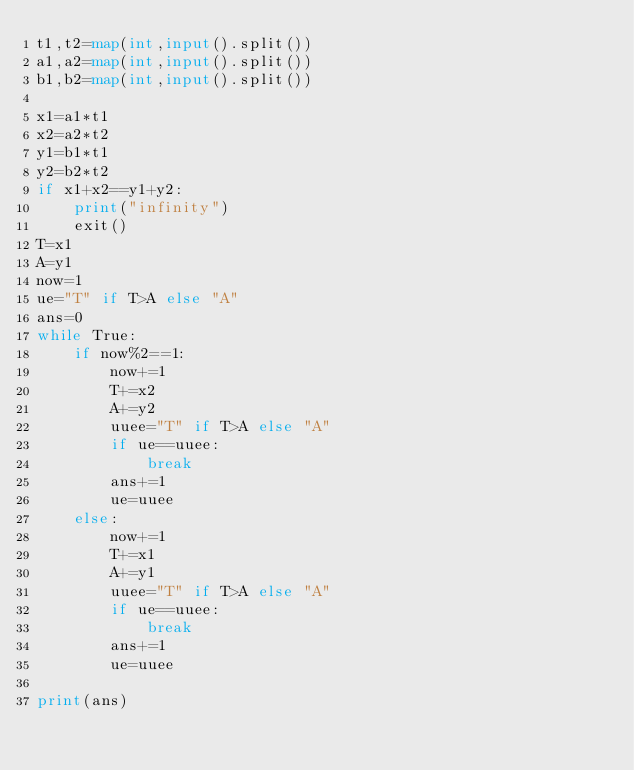Convert code to text. <code><loc_0><loc_0><loc_500><loc_500><_Python_>t1,t2=map(int,input().split())
a1,a2=map(int,input().split())
b1,b2=map(int,input().split())

x1=a1*t1
x2=a2*t2
y1=b1*t1
y2=b2*t2
if x1+x2==y1+y2:
    print("infinity")
    exit()
T=x1
A=y1
now=1
ue="T" if T>A else "A"
ans=0
while True:
    if now%2==1:
        now+=1
        T+=x2
        A+=y2
        uuee="T" if T>A else "A"
        if ue==uuee:
            break
        ans+=1
        ue=uuee
    else:
        now+=1
        T+=x1
        A+=y1
        uuee="T" if T>A else "A"
        if ue==uuee:
            break
        ans+=1
        ue=uuee

print(ans)
</code> 